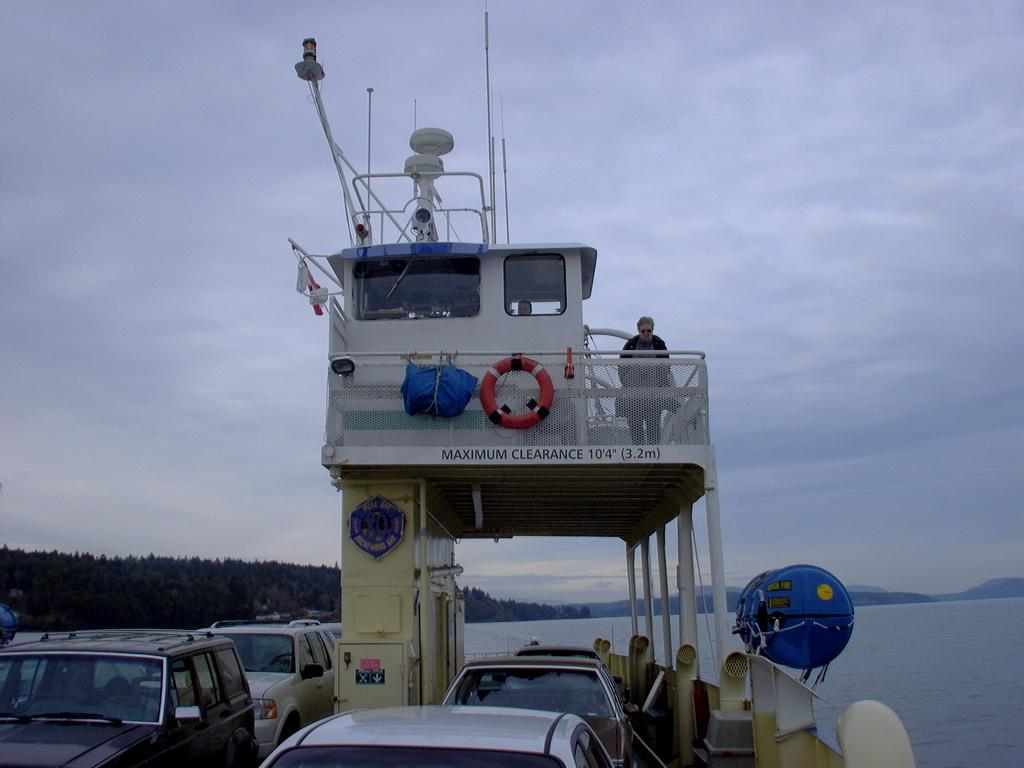How many people are in the image? There are two persons in the image. What object is present in the image that is used for emergency flotation? There is a lifebuoy in the image. What type of vehicles can be seen on the ship? There are hand cars on the ship. Where is the ship located? The ship is on the water. What can be seen behind the ship? There are trees and hills behind the ship. What is visible in the sky in the image? The sky is visible in the image. Where is the throne located in the image? There is no throne present in the image. Can you tell me the direction the ship is heading in the image? The image does not provide information about the direction the ship is heading; it only shows the ship on the water. 